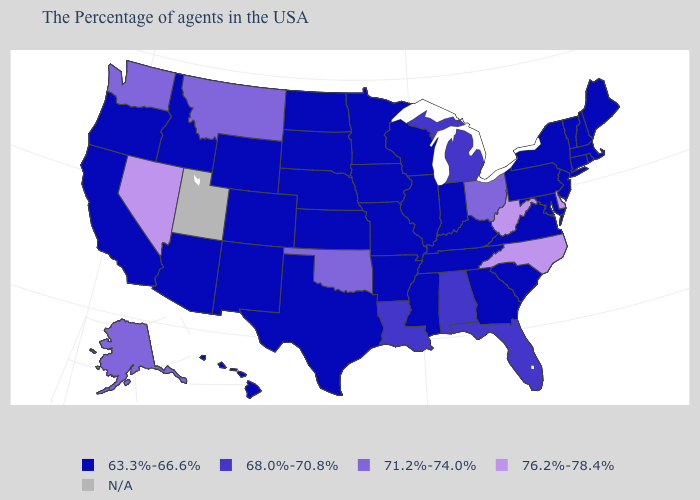What is the value of Oklahoma?
Short answer required. 71.2%-74.0%. Name the states that have a value in the range 76.2%-78.4%?
Give a very brief answer. Delaware, North Carolina, West Virginia, Nevada. Name the states that have a value in the range 63.3%-66.6%?
Short answer required. Maine, Massachusetts, Rhode Island, New Hampshire, Vermont, Connecticut, New York, New Jersey, Maryland, Pennsylvania, Virginia, South Carolina, Georgia, Kentucky, Indiana, Tennessee, Wisconsin, Illinois, Mississippi, Missouri, Arkansas, Minnesota, Iowa, Kansas, Nebraska, Texas, South Dakota, North Dakota, Wyoming, Colorado, New Mexico, Arizona, Idaho, California, Oregon, Hawaii. Name the states that have a value in the range N/A?
Keep it brief. Utah. Which states have the lowest value in the Northeast?
Keep it brief. Maine, Massachusetts, Rhode Island, New Hampshire, Vermont, Connecticut, New York, New Jersey, Pennsylvania. What is the value of Massachusetts?
Short answer required. 63.3%-66.6%. Name the states that have a value in the range 76.2%-78.4%?
Answer briefly. Delaware, North Carolina, West Virginia, Nevada. Name the states that have a value in the range 68.0%-70.8%?
Keep it brief. Florida, Michigan, Alabama, Louisiana. How many symbols are there in the legend?
Keep it brief. 5. What is the lowest value in the USA?
Quick response, please. 63.3%-66.6%. What is the value of Iowa?
Answer briefly. 63.3%-66.6%. Name the states that have a value in the range 68.0%-70.8%?
Keep it brief. Florida, Michigan, Alabama, Louisiana. Name the states that have a value in the range 68.0%-70.8%?
Concise answer only. Florida, Michigan, Alabama, Louisiana. What is the highest value in the USA?
Quick response, please. 76.2%-78.4%. 